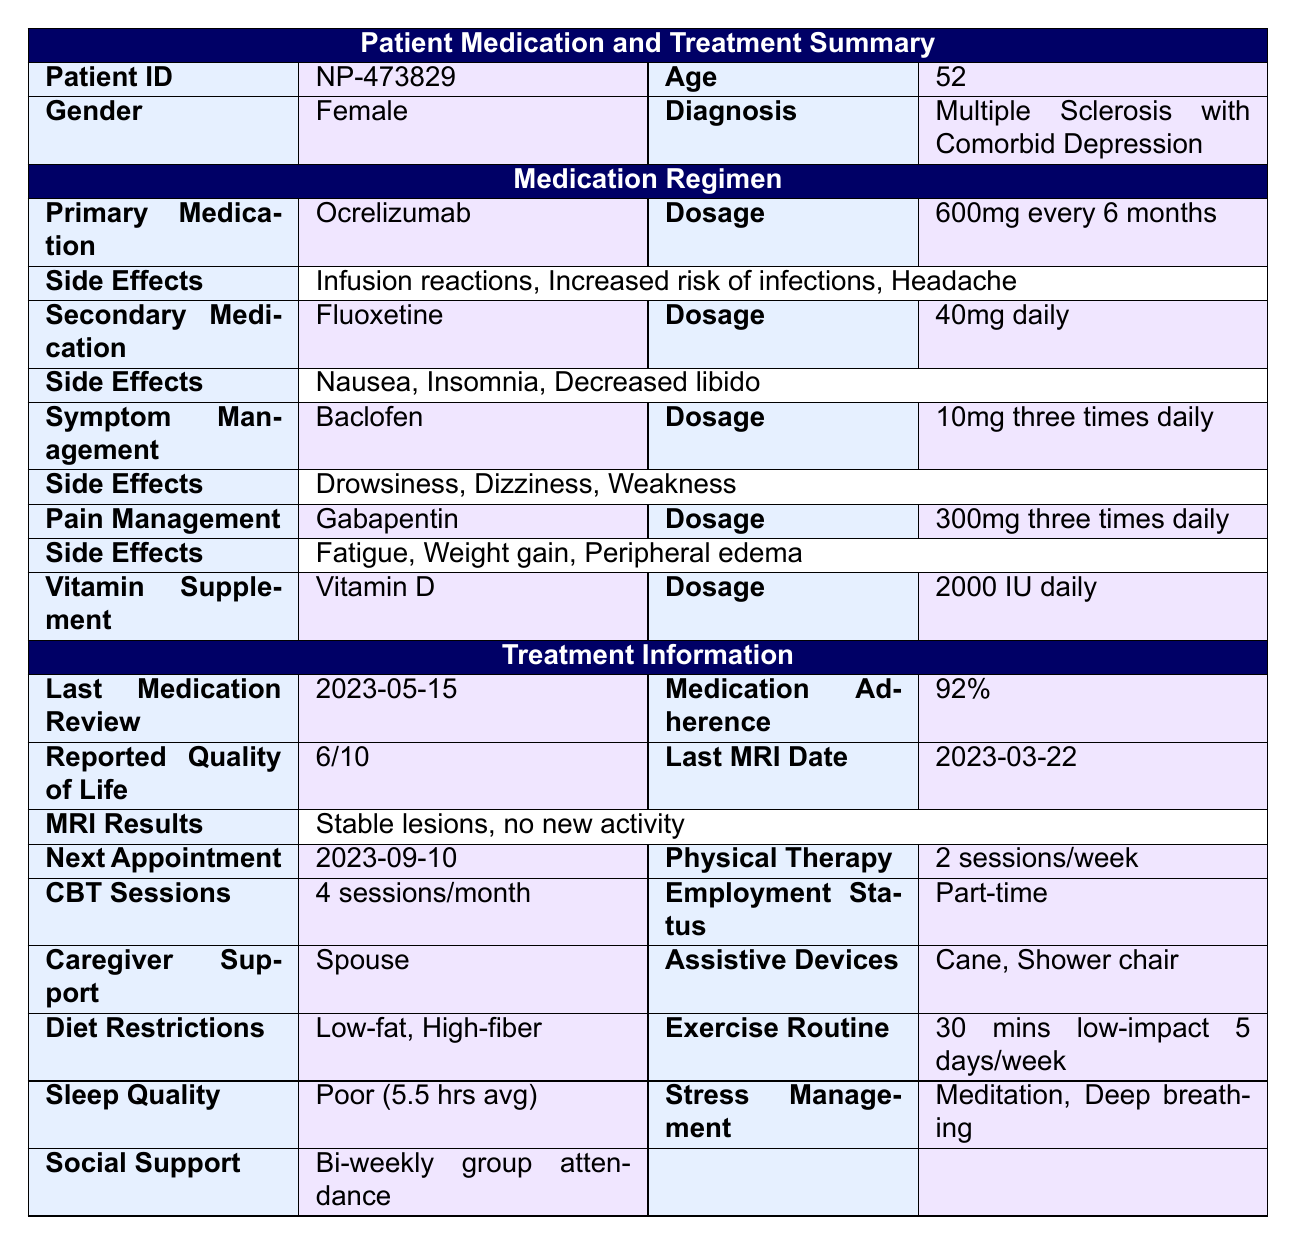What is the primary medication listed for the patient? The table states that the primary medication for the patient is "Ocrelizumab."
Answer: Ocrelizumab What is the dosage of the secondary medication? According to the table, the secondary medication (Fluoxetine) is prescribed at a dosage of "40mg daily."
Answer: 40mg daily How many therapy sessions does the patient attend each month? The table specifies that the patient has "4 sessions/month" for cognitive behavioral therapy.
Answer: 4 sessions/month What are the side effects of Baclofen? The table lists "Drowsiness, Dizziness, Weakness" as the side effects of Baclofen.
Answer: Drowsiness, Dizziness, Weakness Is there a vitamin supplement mentioned in the medication regimen? Yes, the table indicates that Vitamin D is included as a vitamin supplement in the regimen.
Answer: Yes What is the reported quality of life score for the patient? The patient has reported a quality of life score of "6 out of 10" as per the table data.
Answer: 6 out of 10 How often does the patient attend social support groups? The table states the patient has "Bi-weekly group attendance" for social support.
Answer: Bi-weekly What is the average hours of sleep that the patient gets? The table specifies that the average hours of sleep the patient gets is "5.5 hours."
Answer: 5.5 hours If the patient adheres to medication 92% of the time, is it above or below the typical adherence rate? A 92% adherence rate is generally considered above the typical adherence rate, which is often around 80% or lower in chronic conditions.
Answer: Above What is the primary medication’s side effect related to the immune system? One of the side effects of the primary medication, Ocrelizumab, is "Increased risk of infections," which relates to the immune system.
Answer: Increased risk of infections What is the difference in frequency of the primary medication and the symptom management medication? The primary medication (Ocrelizumab) is taken every 6 months, while the symptom management medication (Baclofen) is taken three times daily. This results in a difference of 6 months (or about 180 days) versus 1 day (3 doses), meaning Ocrelizumab is taken much less frequently overall.
Answer: 180 days vs 1 day Given the various side effects listed, how many total distinct side effects are there across all medications? Counting the side effects from each medication, there are 3 from Ocrelizumab, 3 from Fluoxetine, 3 from Baclofen, and 3 from Gabapentin, totaling 12 distinct side effects.
Answer: 12 distinct side effects Does the patient have any caregiver support listed, and if so, who provides it? Yes, the table indicates that the caregiver support is provided by the "Spouse."
Answer: Spouse If the patient has a poor sleep quality rating and averages 5.5 hours of sleep, is that consistent with typical sleep recommendations? The average adult is generally recommended to get 7-9 hours of sleep. Therefore, averaging 5.5 hours is below the recommended amount, indicating poor sleep quality.
Answer: Yes, it is consistent with poor quality 